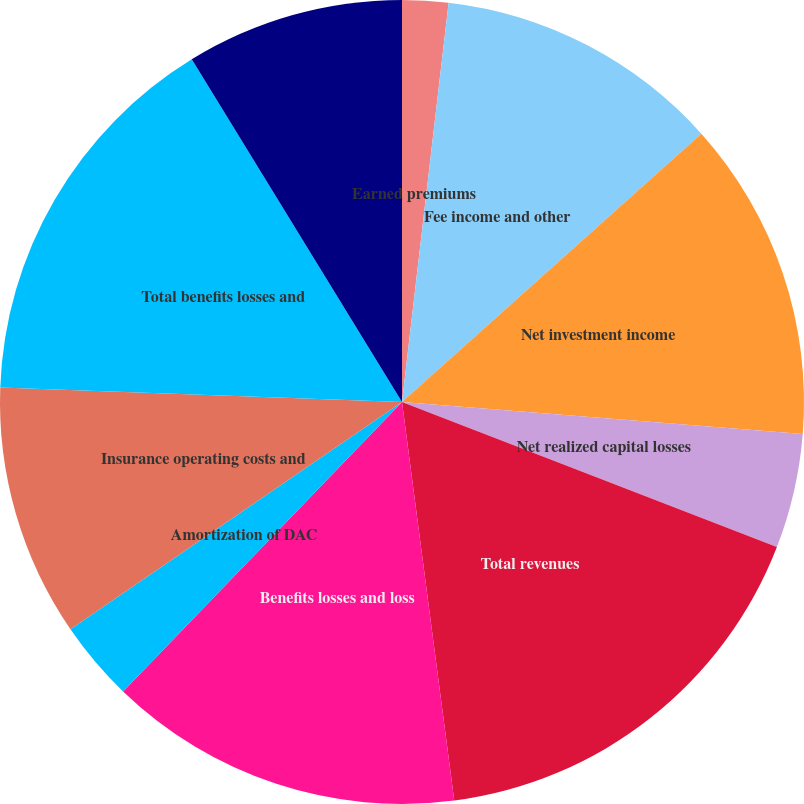Convert chart to OTSL. <chart><loc_0><loc_0><loc_500><loc_500><pie_chart><fcel>Earned premiums<fcel>Fee income and other<fcel>Net investment income<fcel>Net realized capital losses<fcel>Total revenues<fcel>Benefits losses and loss<fcel>Amortization of DAC<fcel>Insurance operating costs and<fcel>Total benefits losses and<fcel>Income before income taxes<nl><fcel>1.85%<fcel>11.52%<fcel>12.9%<fcel>4.61%<fcel>17.05%<fcel>14.28%<fcel>3.23%<fcel>10.14%<fcel>15.67%<fcel>8.76%<nl></chart> 